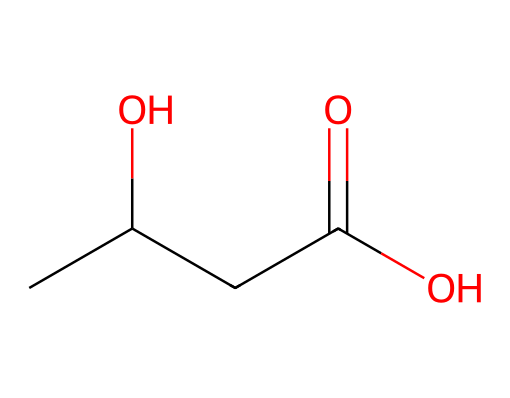What is the main functional group present in this molecule? The functional group present in this molecule can be identified as the carbonyl group (C=O). This is indicative of ketones, where the carbonyl group is connected to two other carbon atoms.
Answer: carbonyl group How many carbon atoms are in this molecule? By analyzing the SMILES representation, we can identify the carbon atoms indicated by the 'C' characters. Counting them, there are four carbon atoms in total.
Answer: four What is the significance of the hydroxyl group in this ketone? The hydroxyl group (–OH) in this molecule signifies that it possesses both ketone and alcohol properties. This dual functionality may enhance its solubility in water and influence its energy-providing characteristics in drinks for active parents.
Answer: dual functionality What is the total number of oxygen atoms in this structure? The SMILES shows two 'O' characters, indicating the presence of two oxygen atoms in the structure.
Answer: two Does this molecule contain any double bonds? The presence of the carbonyl group at the ketone position indicates a double bond between carbon and oxygen (C=O), which is a characteristic of ketones.
Answer: yes Is this molecule an alcohol as well as a ketone? The presence of the hydroxyl group (–OH) means this molecule not only exhibits ketone characteristics due to its carbonyl group but also behaves as an alcohol due to the presence of the hydroxyl group.
Answer: yes 